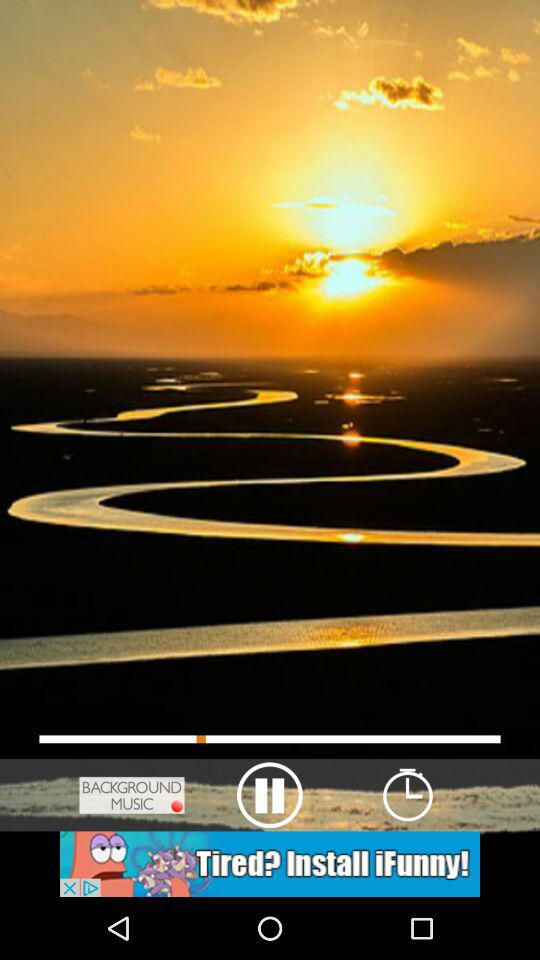Which music is playing?
When the provided information is insufficient, respond with <no answer>. <no answer> 